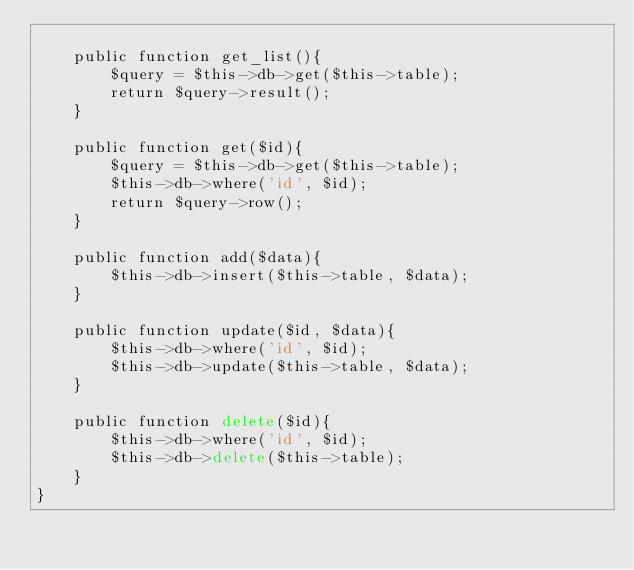Convert code to text. <code><loc_0><loc_0><loc_500><loc_500><_PHP_>
    public function get_list(){
        $query = $this->db->get($this->table);
        return $query->result();
    }

    public function get($id){
        $query = $this->db->get($this->table);
        $this->db->where('id', $id);
        return $query->row();
    }

    public function add($data){
        $this->db->insert($this->table, $data);
    }

    public function update($id, $data){
        $this->db->where('id', $id);
        $this->db->update($this->table, $data);
    }

    public function delete($id){
        $this->db->where('id', $id);
        $this->db->delete($this->table);
    }
}
</code> 